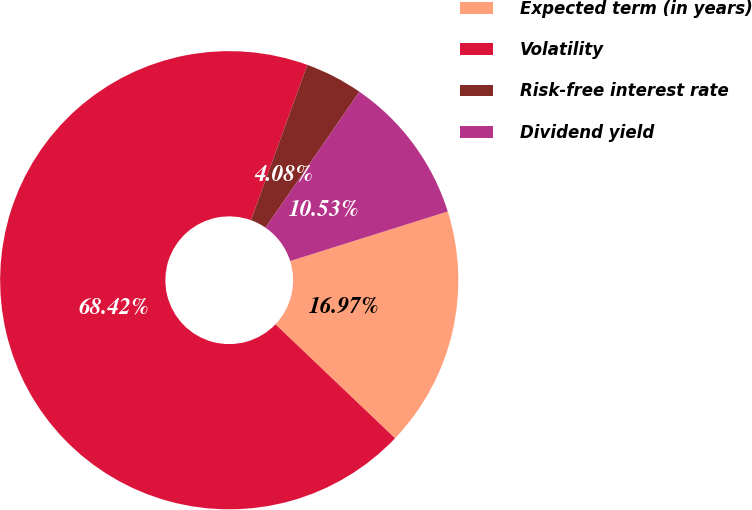Convert chart. <chart><loc_0><loc_0><loc_500><loc_500><pie_chart><fcel>Expected term (in years)<fcel>Volatility<fcel>Risk-free interest rate<fcel>Dividend yield<nl><fcel>16.97%<fcel>68.42%<fcel>4.08%<fcel>10.53%<nl></chart> 